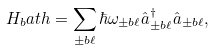Convert formula to latex. <formula><loc_0><loc_0><loc_500><loc_500>H _ { b } a t h = \sum _ { \pm b { \ell } } \hbar { \omega } _ { \pm b { \ell } } \hat { a } _ { \pm b { \ell } } ^ { \dagger } \hat { a } _ { \pm b { \ell } } ,</formula> 